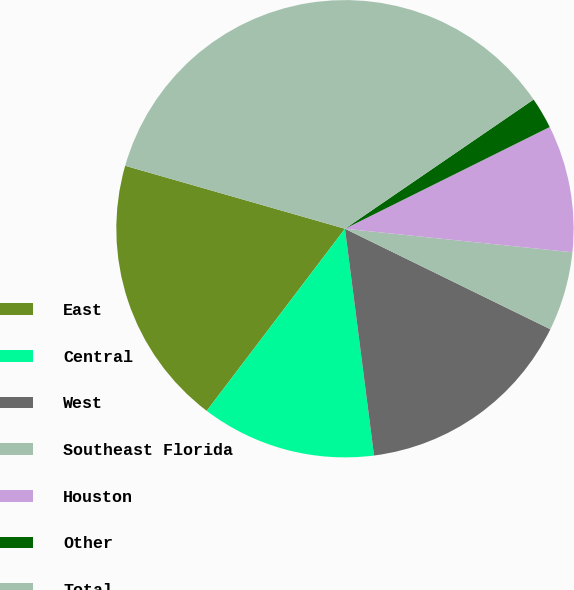<chart> <loc_0><loc_0><loc_500><loc_500><pie_chart><fcel>East<fcel>Central<fcel>West<fcel>Southeast Florida<fcel>Houston<fcel>Other<fcel>Total<nl><fcel>19.11%<fcel>12.36%<fcel>15.73%<fcel>5.6%<fcel>8.98%<fcel>2.22%<fcel>36.0%<nl></chart> 